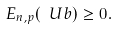Convert formula to latex. <formula><loc_0><loc_0><loc_500><loc_500>E _ { n , p } ( \ U b ) \geq 0 .</formula> 